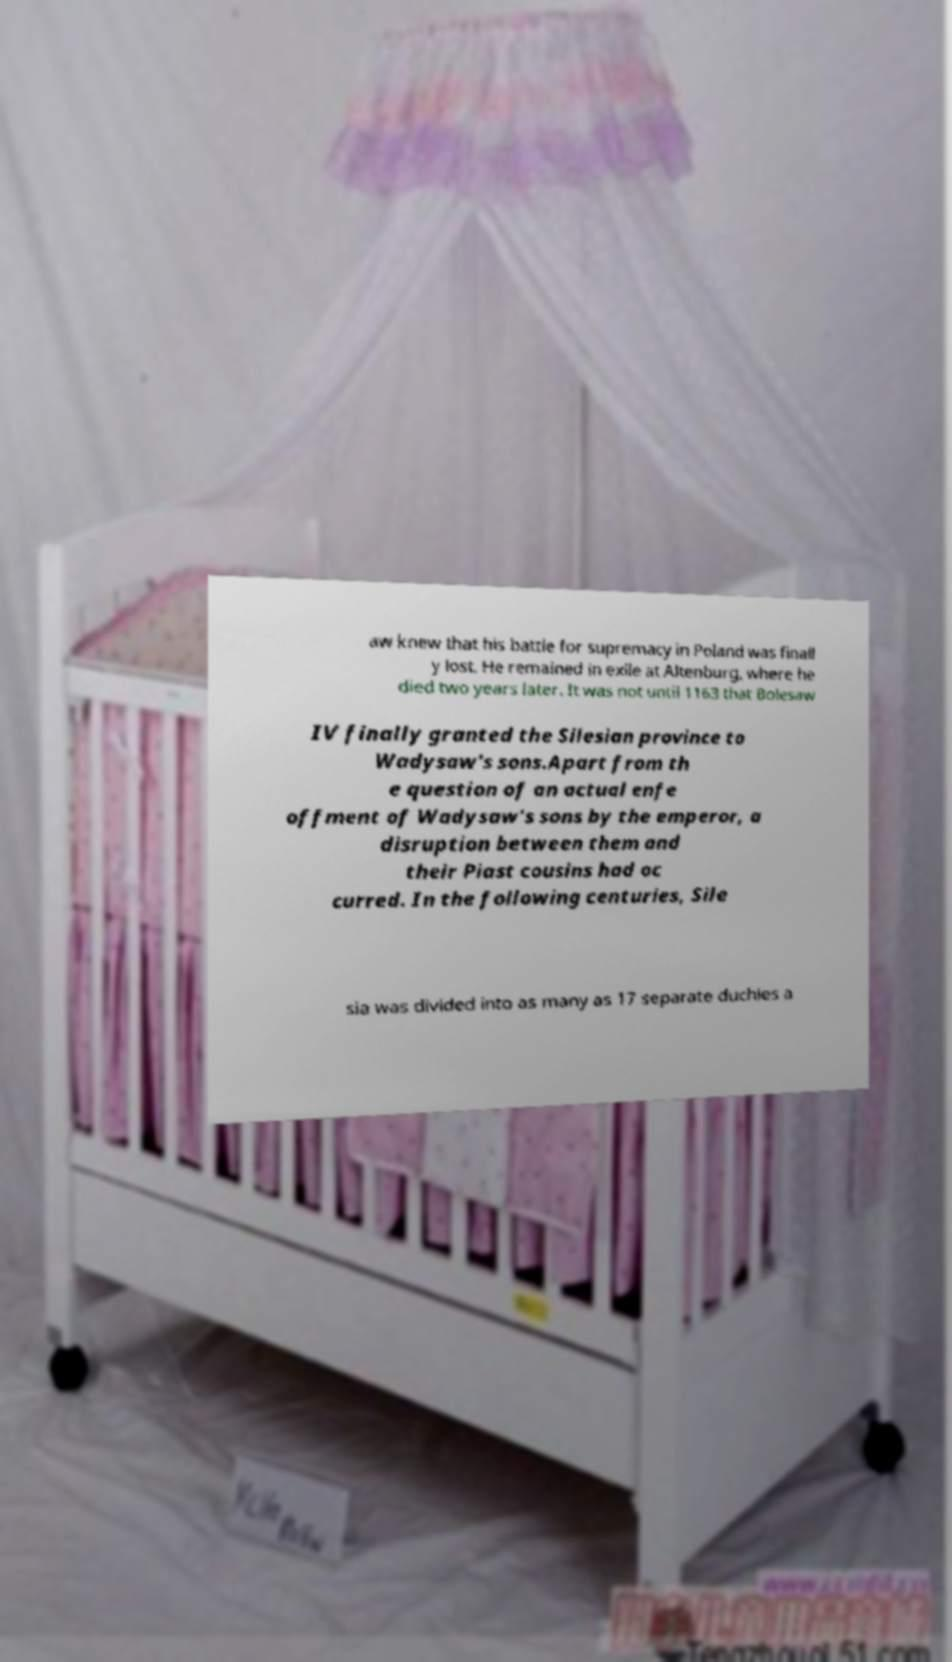I need the written content from this picture converted into text. Can you do that? aw knew that his battle for supremacy in Poland was finall y lost. He remained in exile at Altenburg, where he died two years later. It was not until 1163 that Bolesaw IV finally granted the Silesian province to Wadysaw's sons.Apart from th e question of an actual enfe offment of Wadysaw's sons by the emperor, a disruption between them and their Piast cousins had oc curred. In the following centuries, Sile sia was divided into as many as 17 separate duchies a 